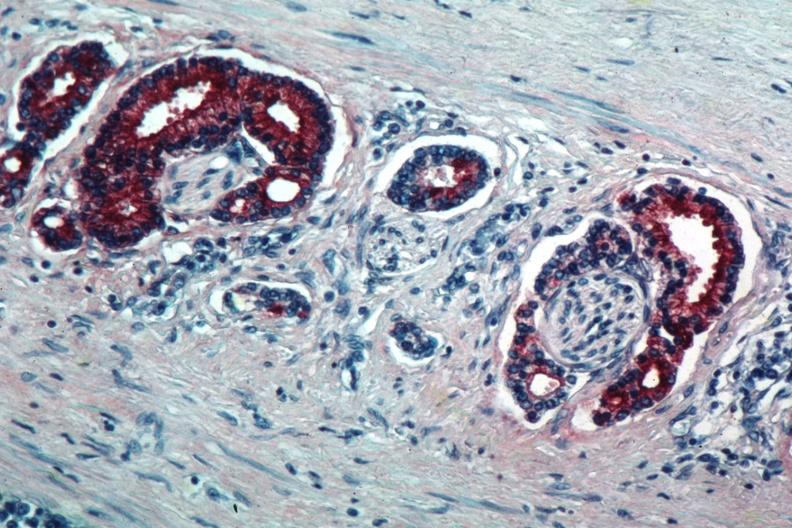s adenocarcinoma present?
Answer the question using a single word or phrase. Yes 